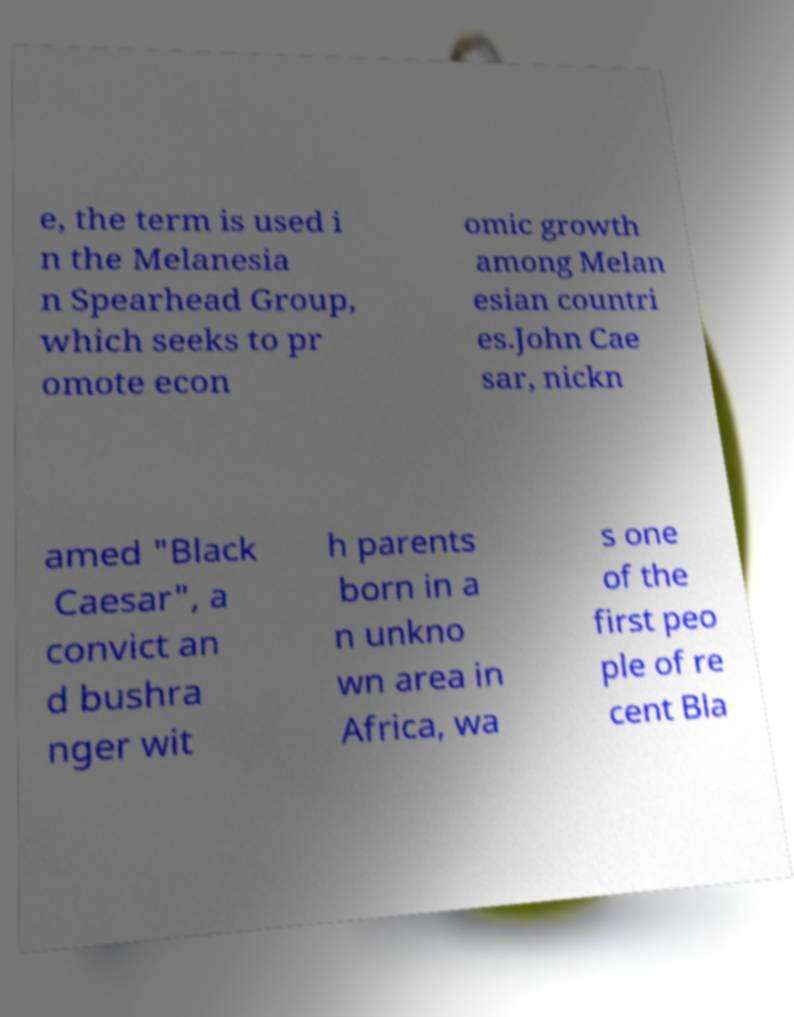Can you read and provide the text displayed in the image?This photo seems to have some interesting text. Can you extract and type it out for me? e, the term is used i n the Melanesia n Spearhead Group, which seeks to pr omote econ omic growth among Melan esian countri es.John Cae sar, nickn amed "Black Caesar", a convict an d bushra nger wit h parents born in a n unkno wn area in Africa, wa s one of the first peo ple of re cent Bla 